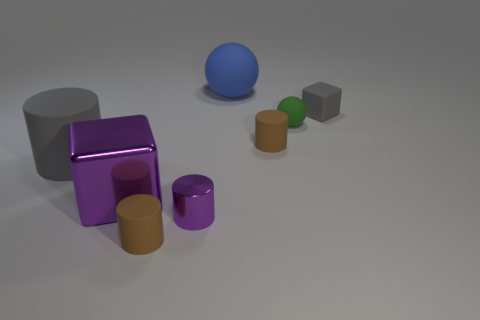Add 1 blue rubber objects. How many objects exist? 9 Subtract all balls. How many objects are left? 6 Add 3 small gray things. How many small gray things are left? 4 Add 5 rubber cubes. How many rubber cubes exist? 6 Subtract 0 purple spheres. How many objects are left? 8 Subtract all metallic cubes. Subtract all small brown matte cylinders. How many objects are left? 5 